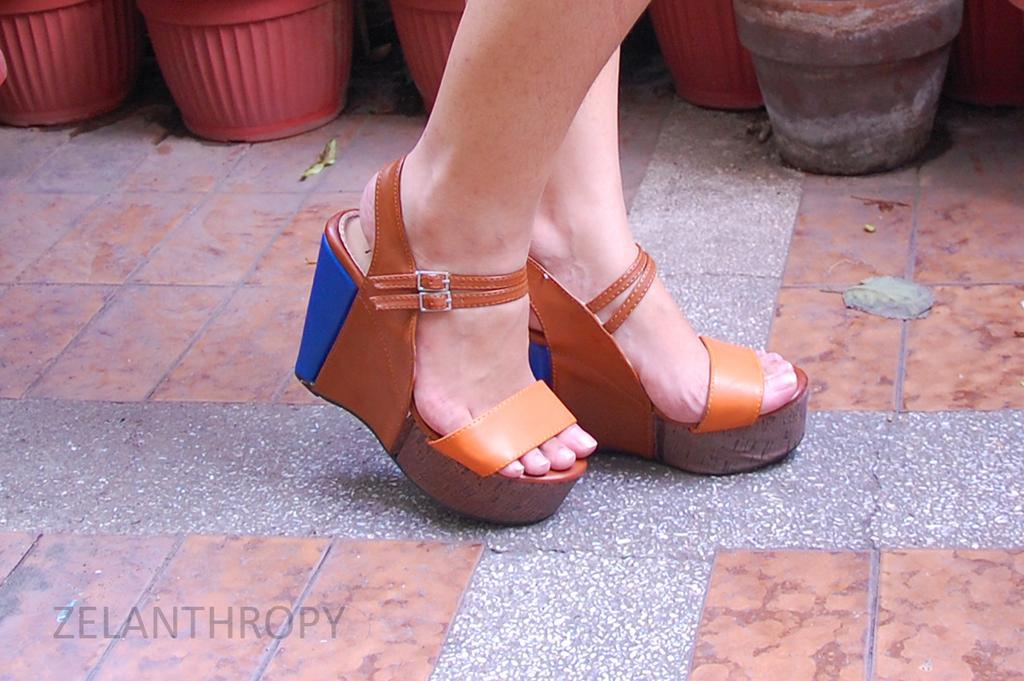How would you summarize this image in a sentence or two? In this image there is some women wearing heels and standing on the ground. In the background there are six flower pots. There is also a logo. 